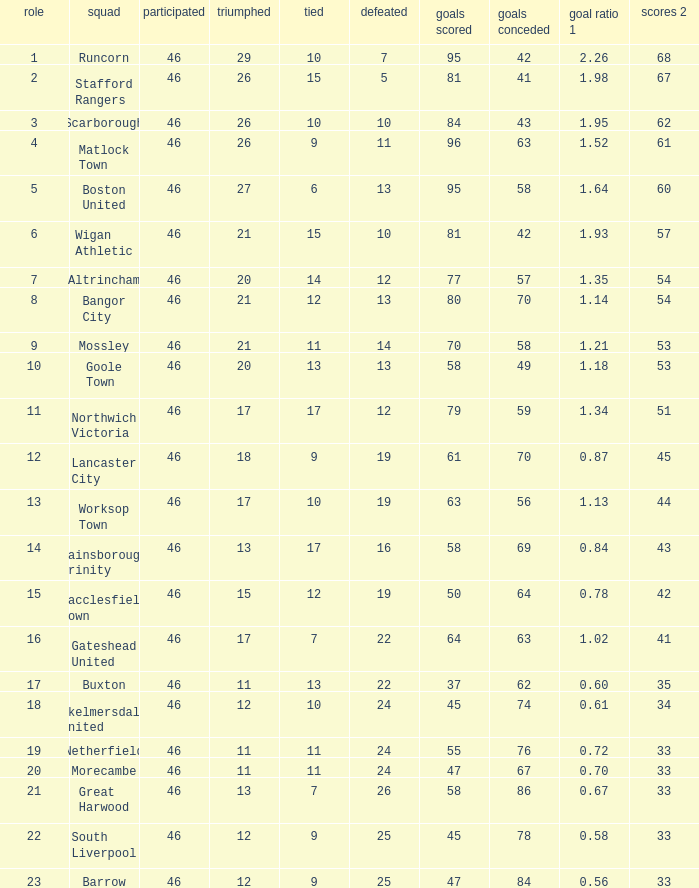How many times did the Lancaster City team play? 1.0. 